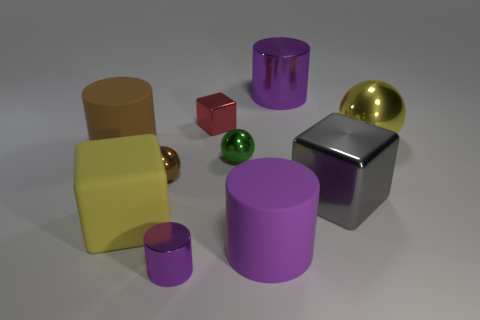What is the size of the green ball that is the same material as the red cube?
Provide a short and direct response. Small. How many other shiny blocks have the same color as the small metal cube?
Make the answer very short. 0. There is a big gray thing; are there any purple metal things to the right of it?
Your answer should be compact. No. Do the green shiny thing and the big purple thing that is to the right of the purple rubber cylinder have the same shape?
Provide a succinct answer. No. What number of objects are either rubber cylinders that are in front of the gray metal object or matte objects?
Offer a terse response. 3. Is there any other thing that is made of the same material as the red thing?
Ensure brevity in your answer.  Yes. How many purple metal cylinders are in front of the yellow metal thing and behind the small red block?
Offer a very short reply. 0. How many things are either cylinders to the left of the small brown metallic object or cubes that are in front of the yellow shiny ball?
Your response must be concise. 3. What number of other objects are there of the same shape as the big gray object?
Make the answer very short. 2. Do the rubber cylinder that is left of the tiny red thing and the big metal cube have the same color?
Keep it short and to the point. No. 